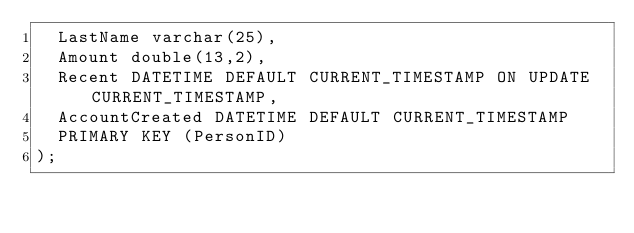Convert code to text. <code><loc_0><loc_0><loc_500><loc_500><_SQL_>	LastName varchar(25),
	Amount double(13,2),
	Recent DATETIME DEFAULT CURRENT_TIMESTAMP ON UPDATE CURRENT_TIMESTAMP,
	AccountCreated DATETIME DEFAULT CURRENT_TIMESTAMP
	PRIMARY KEY (PersonID)
);</code> 